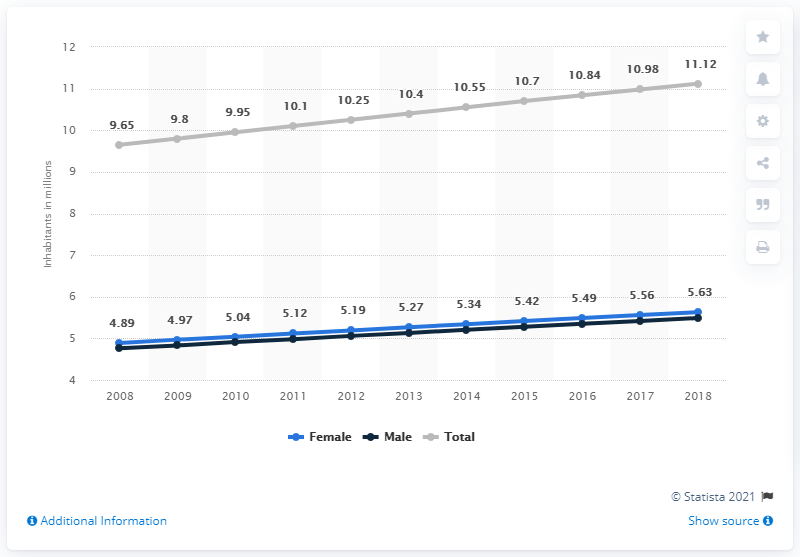Point out several critical features in this image. In 2018, the population of Haiti was approximately 11.12 million. In 2018, an estimated 5.63 million women lived in Haiti. In 2008, the population of Haiti began to show a marked upward trend. 